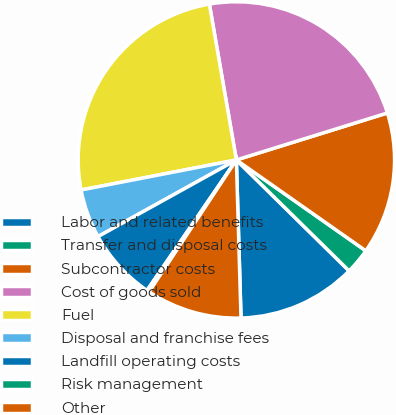<chart> <loc_0><loc_0><loc_500><loc_500><pie_chart><fcel>Labor and related benefits<fcel>Transfer and disposal costs<fcel>Subcontractor costs<fcel>Cost of goods sold<fcel>Fuel<fcel>Disposal and franchise fees<fcel>Landfill operating costs<fcel>Risk management<fcel>Other<nl><fcel>12.16%<fcel>2.63%<fcel>14.54%<fcel>22.93%<fcel>25.31%<fcel>5.01%<fcel>7.39%<fcel>0.25%<fcel>9.77%<nl></chart> 